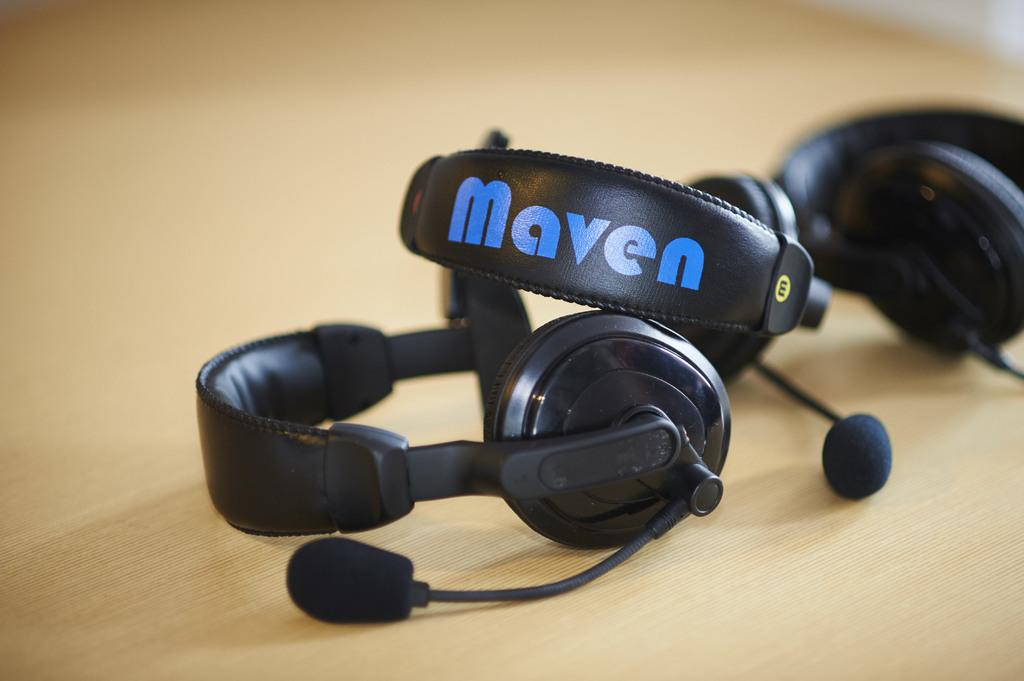What type of objects are on the table in the image? There are headsets on the table in the image. What might the headsets be used for? The headsets might be used for listening to audio or for communication purposes. Can you describe the table in the image? The table is where the headsets are placed in the image. What type of hair is visible on the headsets in the image? There is no hair visible on the headsets in the image. How many cards are placed on the table with the headsets in the image? There are no cards present in the image; only headsets are visible on the table. 